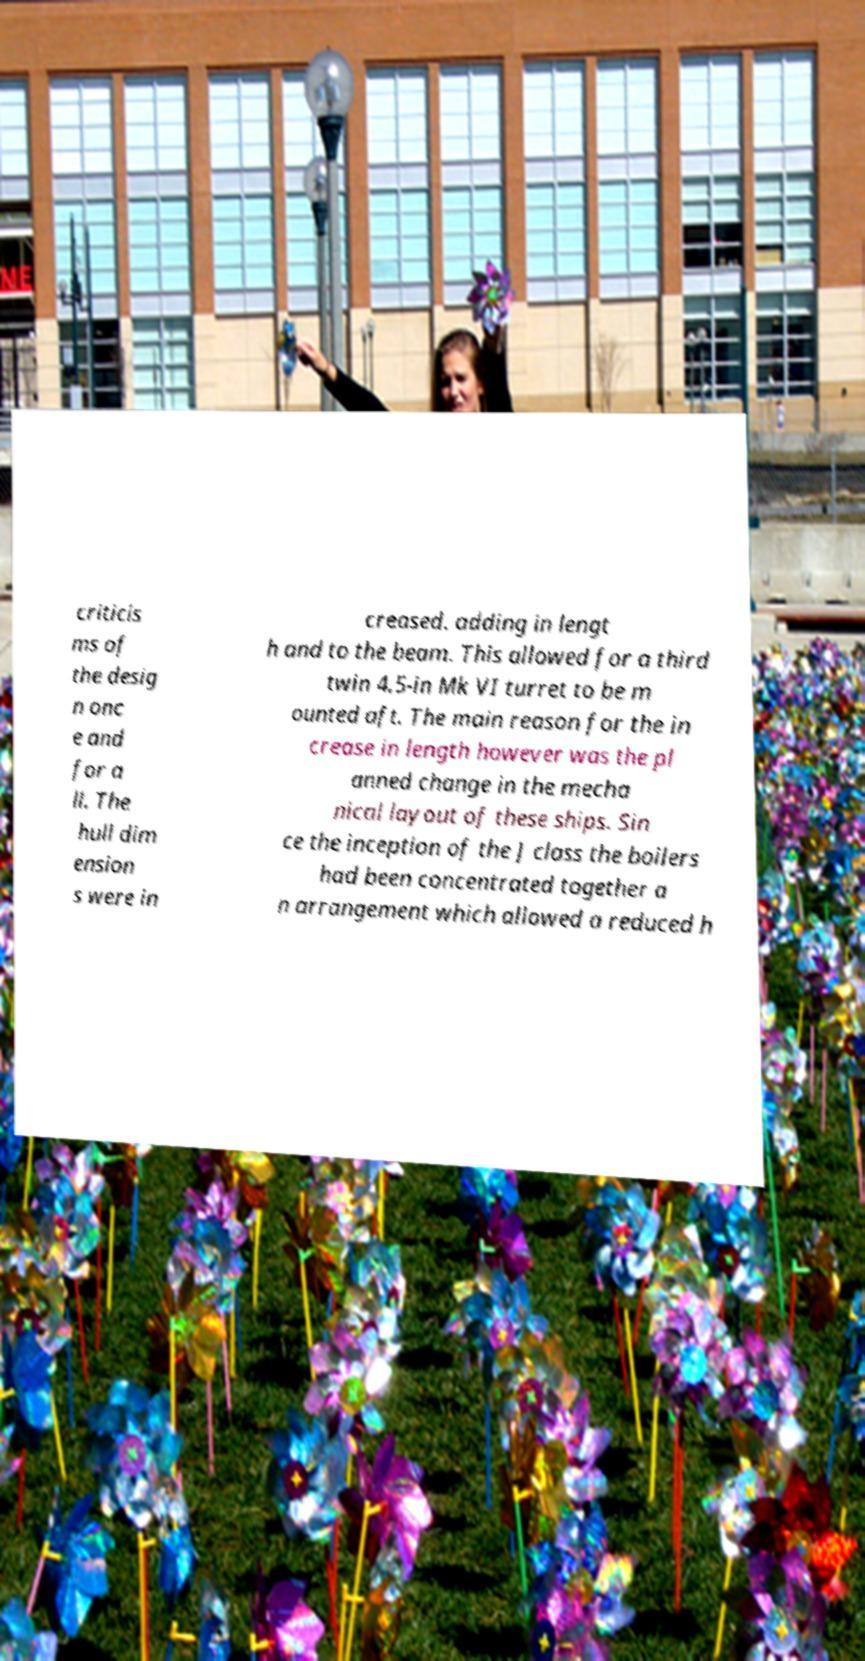For documentation purposes, I need the text within this image transcribed. Could you provide that? criticis ms of the desig n onc e and for a ll. The hull dim ension s were in creased. adding in lengt h and to the beam. This allowed for a third twin 4.5-in Mk VI turret to be m ounted aft. The main reason for the in crease in length however was the pl anned change in the mecha nical layout of these ships. Sin ce the inception of the J class the boilers had been concentrated together a n arrangement which allowed a reduced h 